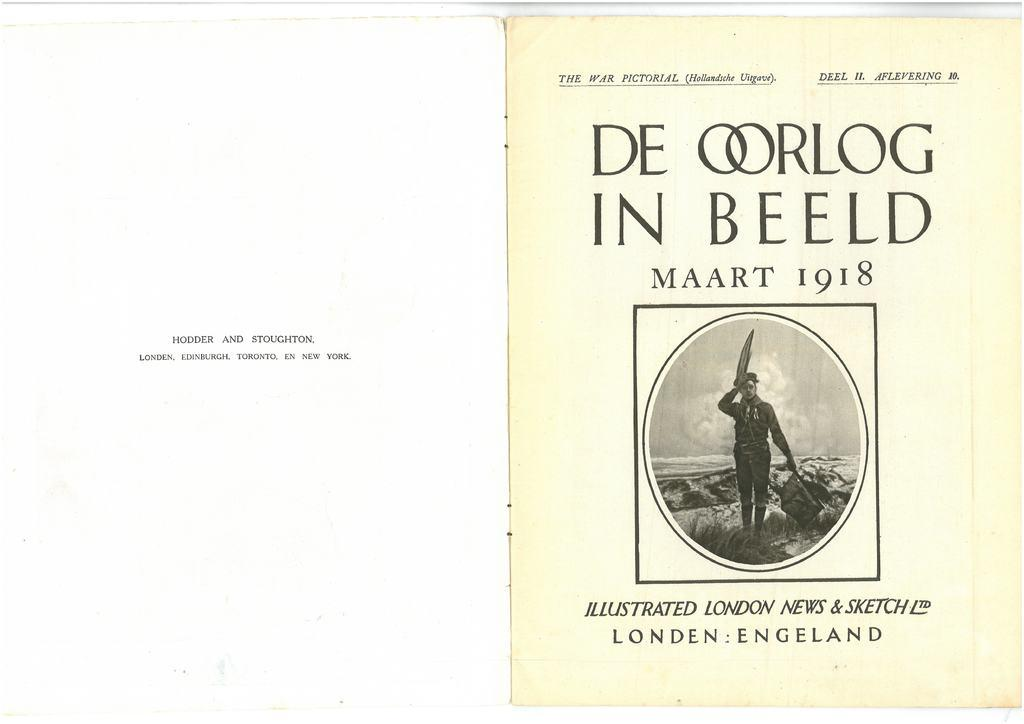<image>
Describe the image concisely. a book that says 'de oorlog in beeld' on the cover of it 